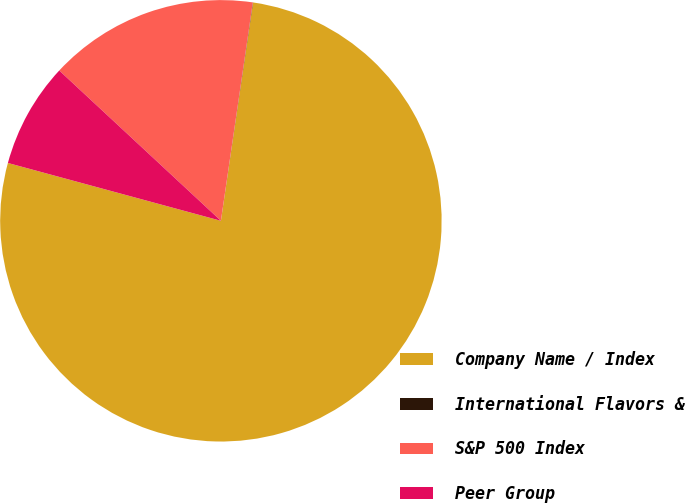<chart> <loc_0><loc_0><loc_500><loc_500><pie_chart><fcel>Company Name / Index<fcel>International Flavors &<fcel>S&P 500 Index<fcel>Peer Group<nl><fcel>76.89%<fcel>0.02%<fcel>15.39%<fcel>7.7%<nl></chart> 